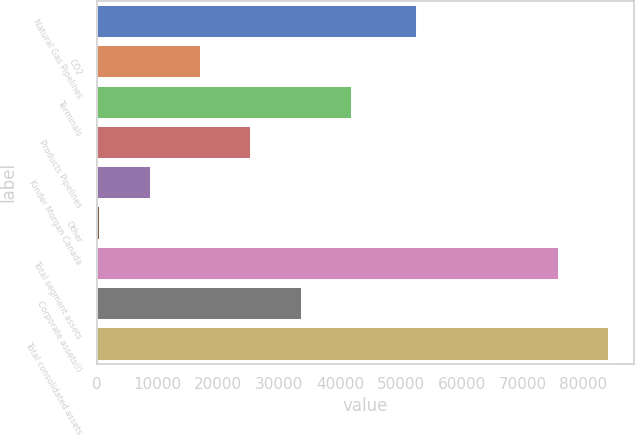Convert chart. <chart><loc_0><loc_0><loc_500><loc_500><bar_chart><fcel>Natural Gas Pipelines<fcel>CO2<fcel>Terminals<fcel>Products Pipelines<fcel>Kinder Morgan Canada<fcel>Other<fcel>Total segment assets<fcel>Corporate assets(l)<fcel>Total consolidated assets<nl><fcel>52523<fcel>17006.8<fcel>41828.5<fcel>25280.7<fcel>8732.9<fcel>459<fcel>75831<fcel>33554.6<fcel>84104.9<nl></chart> 